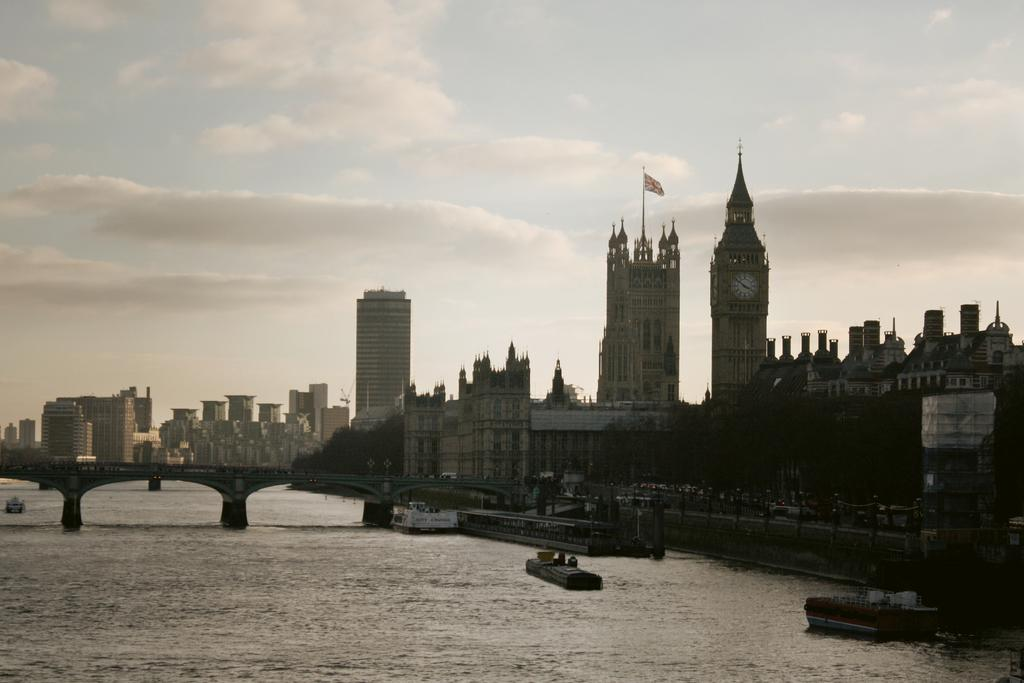What can be seen in the sky in the image? Clouds are visible in the image. What type of structures are present in the image? There are buildings in the image. What type of vegetation is present in the image? Trees are present in the image. What natural element can be seen in the image? There is water visible in the image. What symbol is present in the image? There is a flag in the image. What type of man-made structure is present in the image? There is a bridge in the image. What type of button is being used by the police in the afternoon in the image? There is no button or police present in the image, and the time of day is not mentioned. 